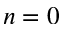Convert formula to latex. <formula><loc_0><loc_0><loc_500><loc_500>n = 0</formula> 